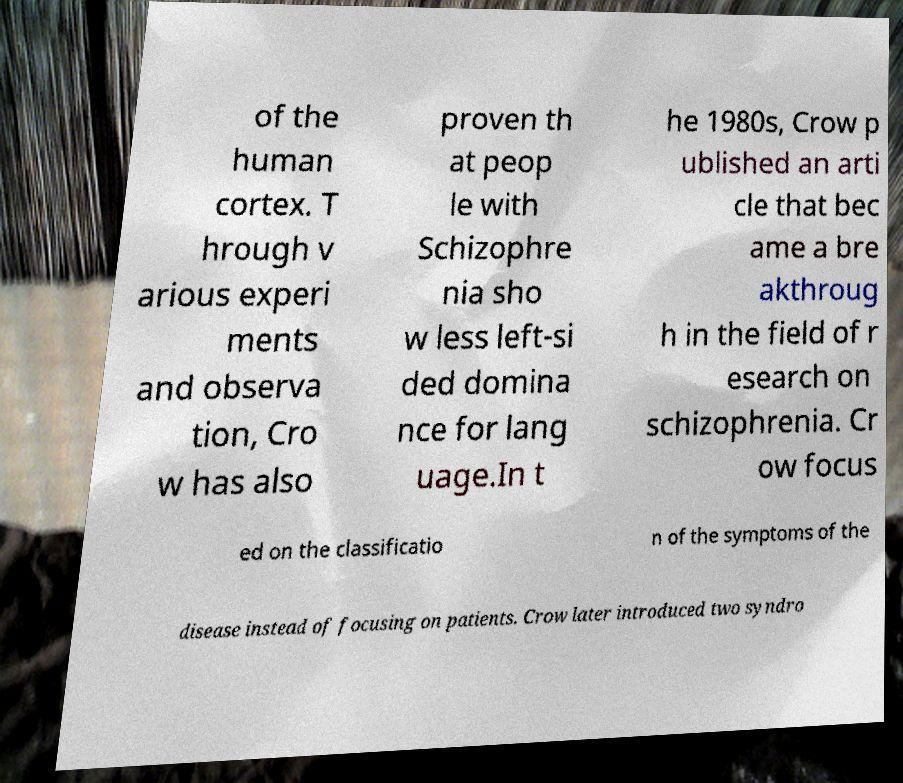For documentation purposes, I need the text within this image transcribed. Could you provide that? of the human cortex. T hrough v arious experi ments and observa tion, Cro w has also proven th at peop le with Schizophre nia sho w less left-si ded domina nce for lang uage.In t he 1980s, Crow p ublished an arti cle that bec ame a bre akthroug h in the field of r esearch on schizophrenia. Cr ow focus ed on the classificatio n of the symptoms of the disease instead of focusing on patients. Crow later introduced two syndro 